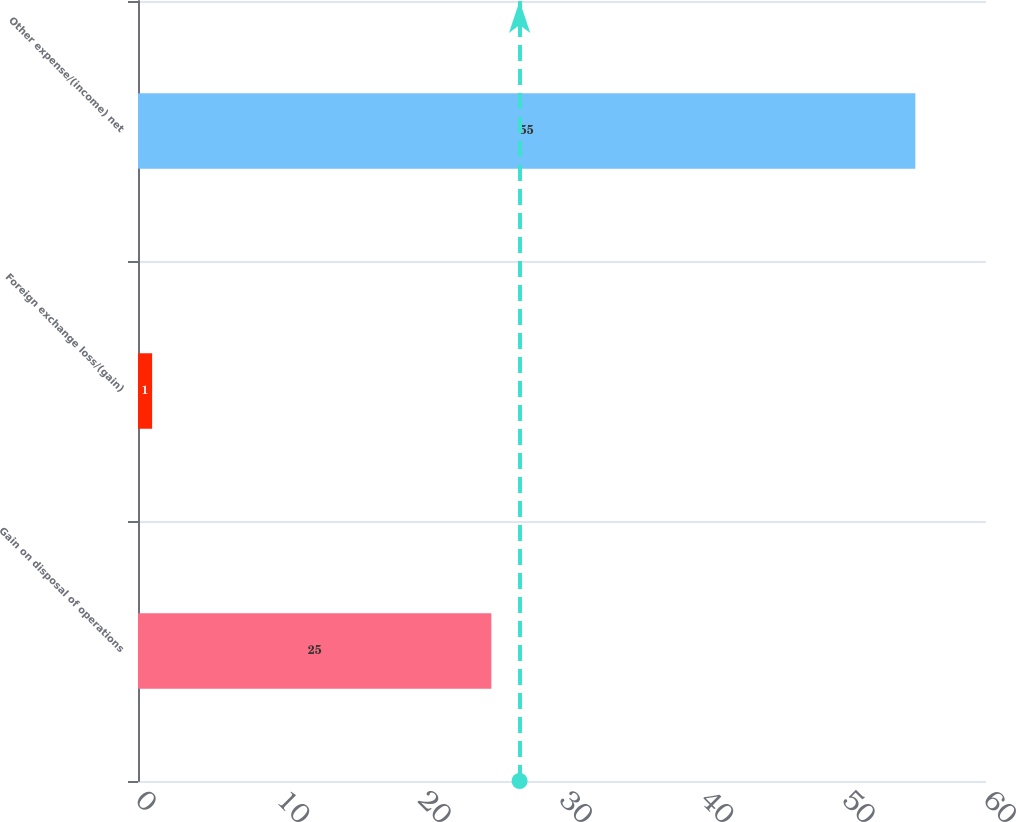Convert chart. <chart><loc_0><loc_0><loc_500><loc_500><bar_chart><fcel>Gain on disposal of operations<fcel>Foreign exchange loss/(gain)<fcel>Other expense/(income) net<nl><fcel>25<fcel>1<fcel>55<nl></chart> 